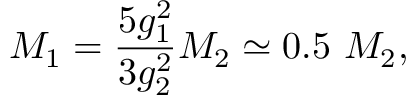<formula> <loc_0><loc_0><loc_500><loc_500>M _ { 1 } = { \frac { 5 g _ { 1 } ^ { 2 } } { 3 g _ { 2 } ^ { 2 } } } M _ { 2 } \simeq 0 . 5 M _ { 2 } ,</formula> 